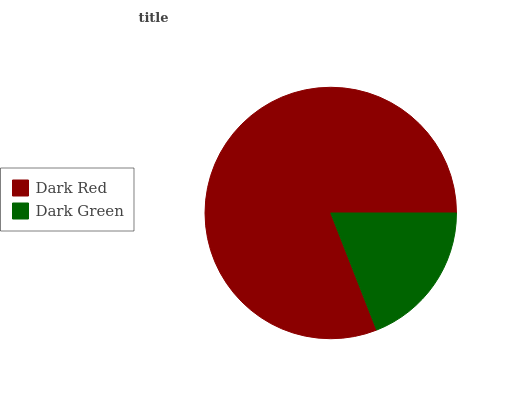Is Dark Green the minimum?
Answer yes or no. Yes. Is Dark Red the maximum?
Answer yes or no. Yes. Is Dark Green the maximum?
Answer yes or no. No. Is Dark Red greater than Dark Green?
Answer yes or no. Yes. Is Dark Green less than Dark Red?
Answer yes or no. Yes. Is Dark Green greater than Dark Red?
Answer yes or no. No. Is Dark Red less than Dark Green?
Answer yes or no. No. Is Dark Red the high median?
Answer yes or no. Yes. Is Dark Green the low median?
Answer yes or no. Yes. Is Dark Green the high median?
Answer yes or no. No. Is Dark Red the low median?
Answer yes or no. No. 